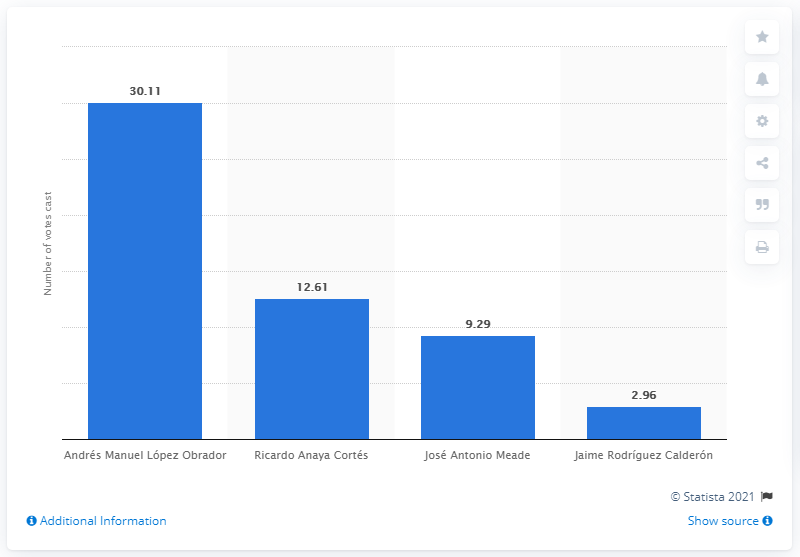Can you give me a comparison of the votes received by the top two candidates? Sure, Andrés Manuel López Obrador received the highest number of votes at 30.11 million, while Ricardo Anaya Cortés, the runner-up, received 12.61 million votes. This shows a significant lead by López Obrador, with roughly a 17.5 million vote difference. 